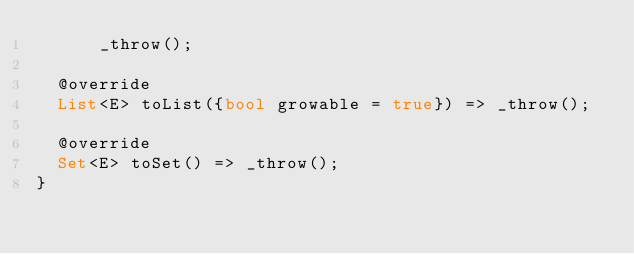<code> <loc_0><loc_0><loc_500><loc_500><_Dart_>      _throw();

  @override
  List<E> toList({bool growable = true}) => _throw();

  @override
  Set<E> toSet() => _throw();
}
</code> 